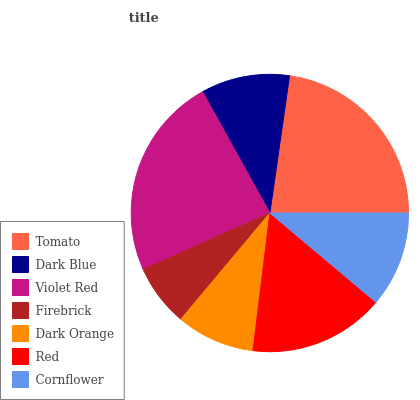Is Firebrick the minimum?
Answer yes or no. Yes. Is Violet Red the maximum?
Answer yes or no. Yes. Is Dark Blue the minimum?
Answer yes or no. No. Is Dark Blue the maximum?
Answer yes or no. No. Is Tomato greater than Dark Blue?
Answer yes or no. Yes. Is Dark Blue less than Tomato?
Answer yes or no. Yes. Is Dark Blue greater than Tomato?
Answer yes or no. No. Is Tomato less than Dark Blue?
Answer yes or no. No. Is Cornflower the high median?
Answer yes or no. Yes. Is Cornflower the low median?
Answer yes or no. Yes. Is Dark Orange the high median?
Answer yes or no. No. Is Dark Blue the low median?
Answer yes or no. No. 